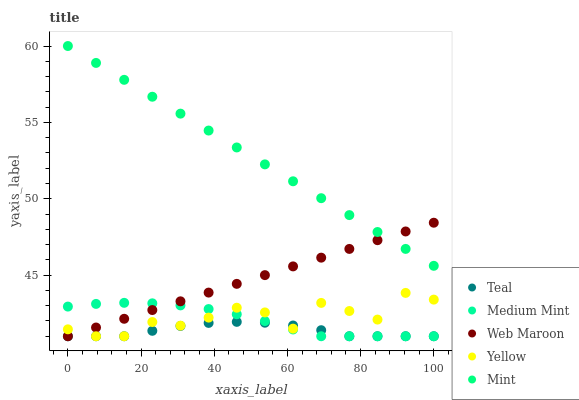Does Teal have the minimum area under the curve?
Answer yes or no. Yes. Does Mint have the maximum area under the curve?
Answer yes or no. Yes. Does Web Maroon have the minimum area under the curve?
Answer yes or no. No. Does Web Maroon have the maximum area under the curve?
Answer yes or no. No. Is Mint the smoothest?
Answer yes or no. Yes. Is Yellow the roughest?
Answer yes or no. Yes. Is Web Maroon the smoothest?
Answer yes or no. No. Is Web Maroon the roughest?
Answer yes or no. No. Does Medium Mint have the lowest value?
Answer yes or no. Yes. Does Mint have the lowest value?
Answer yes or no. No. Does Mint have the highest value?
Answer yes or no. Yes. Does Web Maroon have the highest value?
Answer yes or no. No. Is Medium Mint less than Mint?
Answer yes or no. Yes. Is Mint greater than Medium Mint?
Answer yes or no. Yes. Does Yellow intersect Teal?
Answer yes or no. Yes. Is Yellow less than Teal?
Answer yes or no. No. Is Yellow greater than Teal?
Answer yes or no. No. Does Medium Mint intersect Mint?
Answer yes or no. No. 